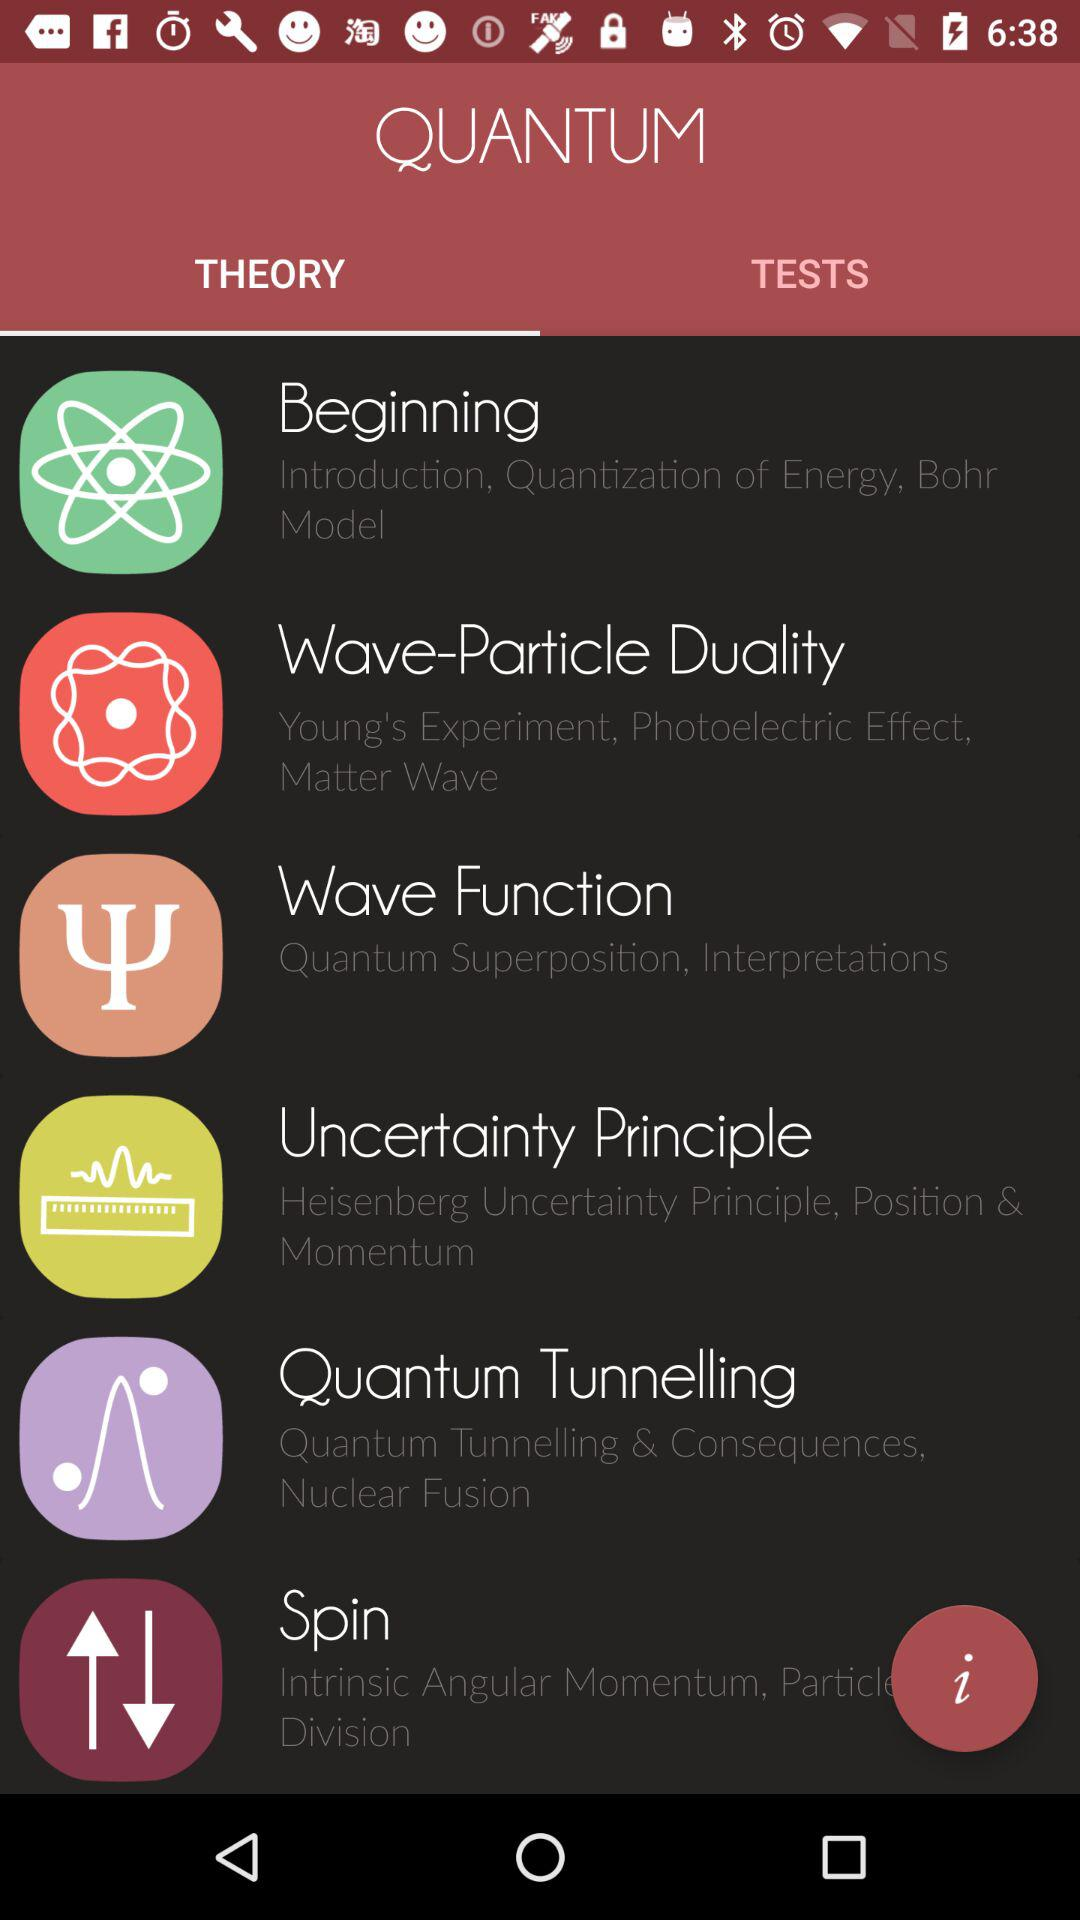Which tab is selected? The selected tab is Theory. 